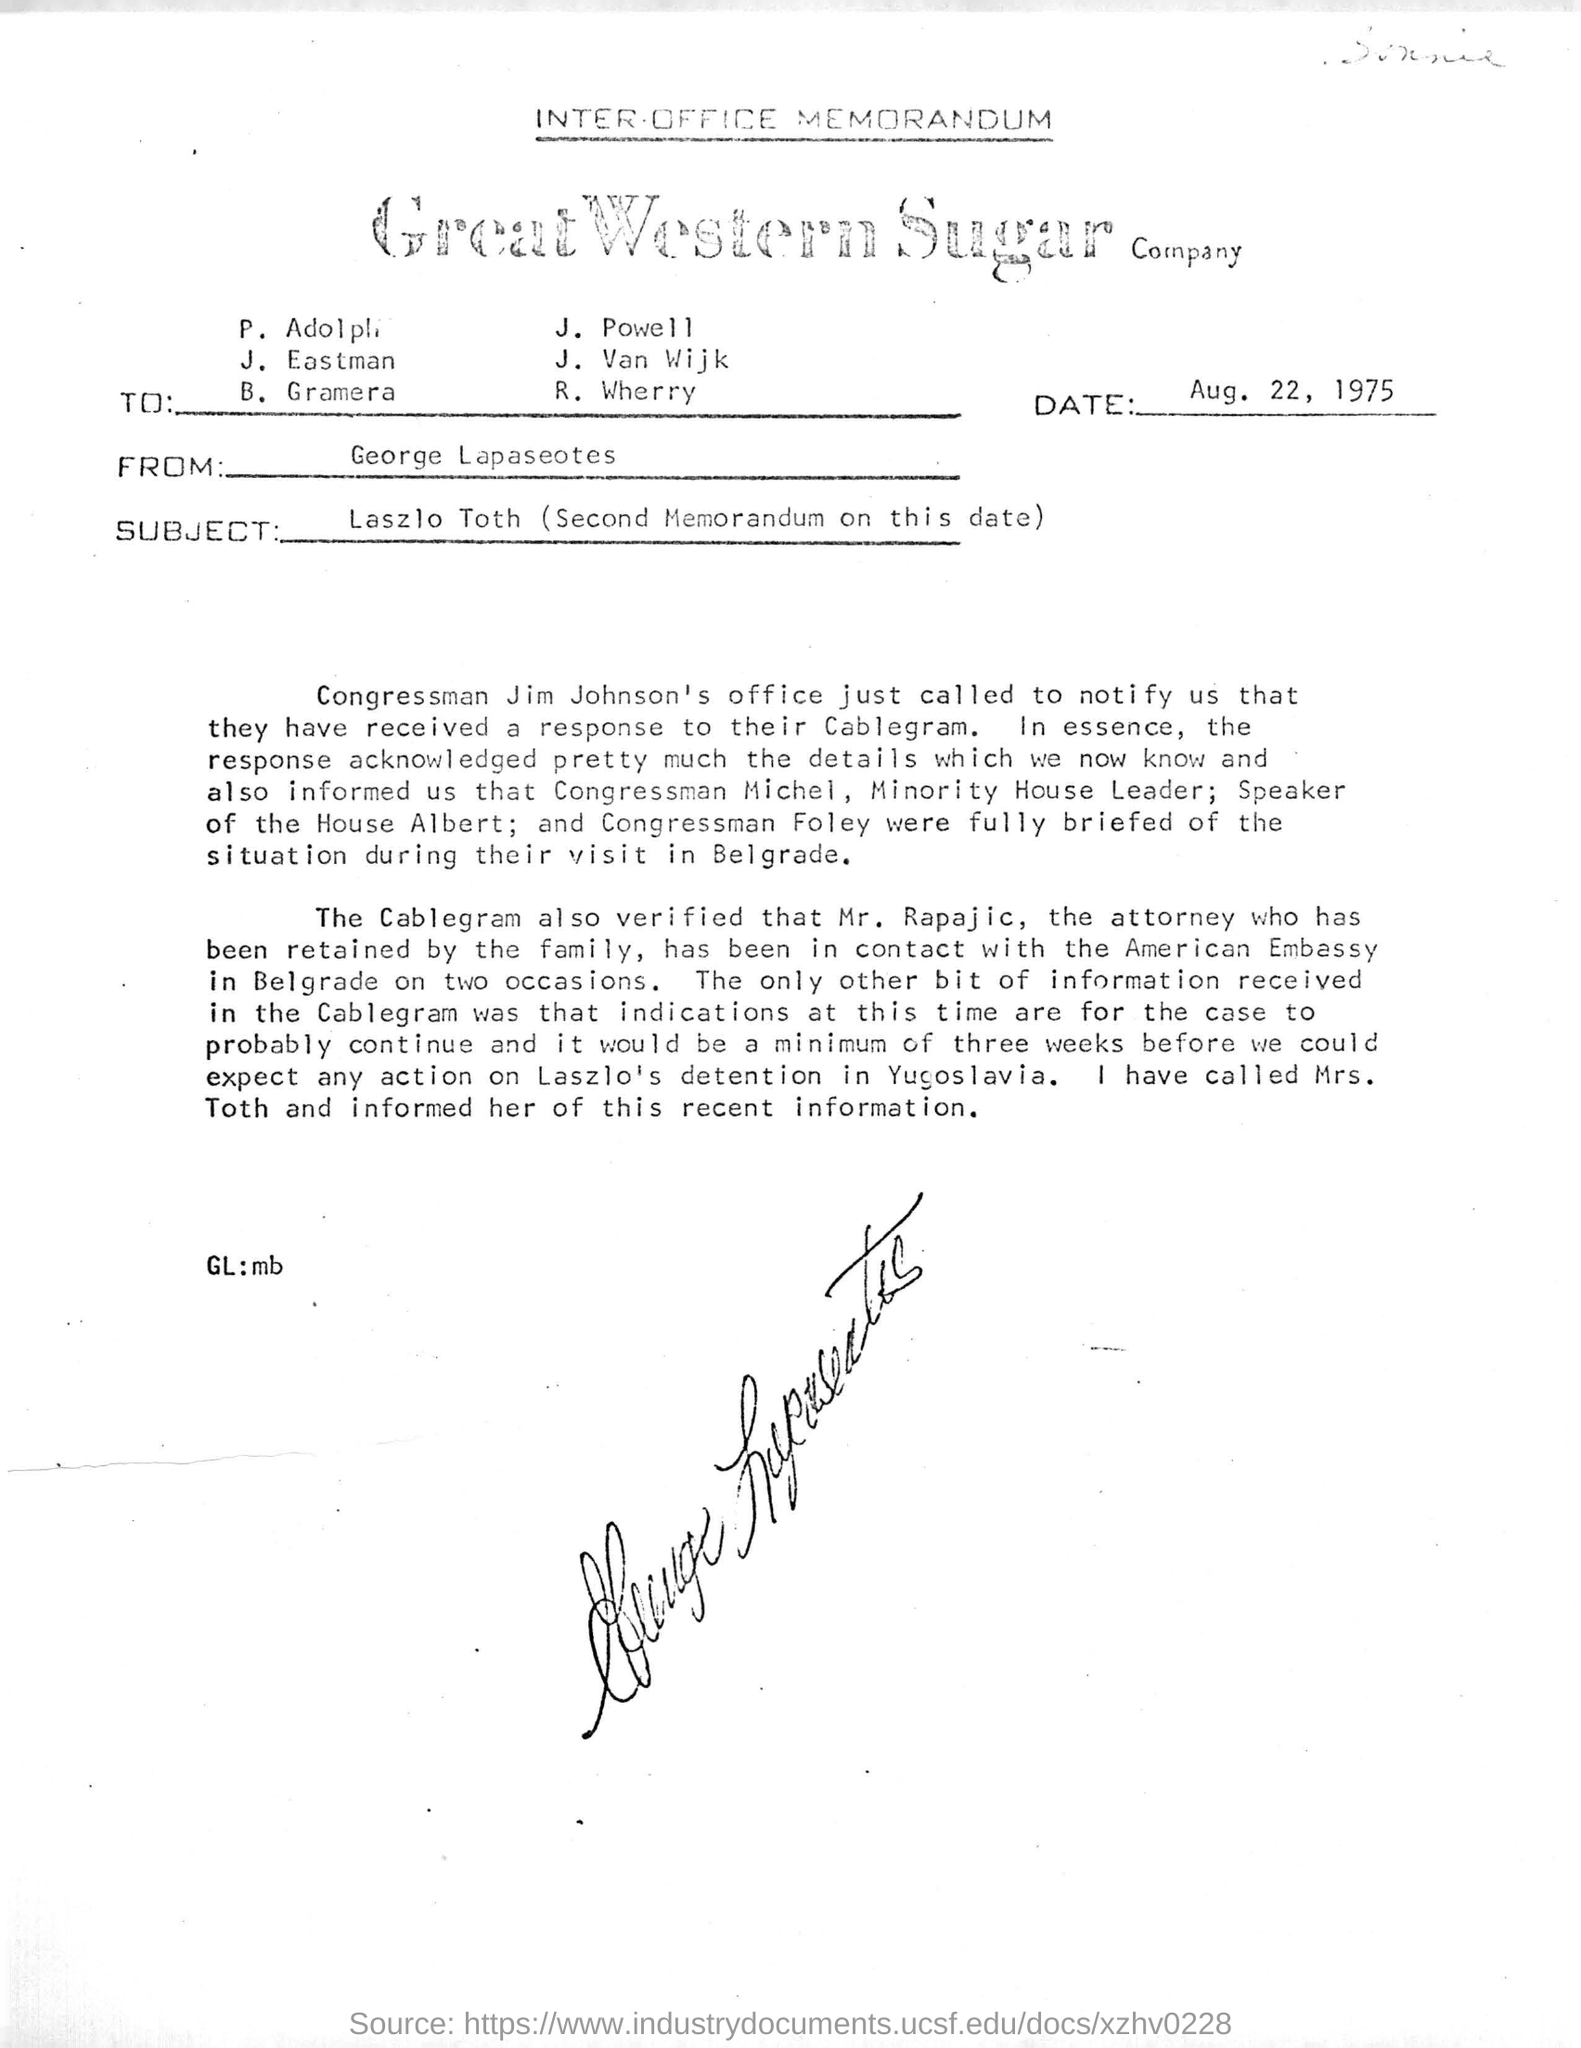What is the date of this document?
Give a very brief answer. Aug. 22, 1975. Who is the sender of this letter?
Offer a terse response. George Lapaseotes. What is the subject of this memorandum?
Ensure brevity in your answer.  Laszlo Toth (Second Memorandum on this date). Who is speaker of the house?
Offer a very short reply. Albert. Who is the minority House leader?
Give a very brief answer. Michel. 